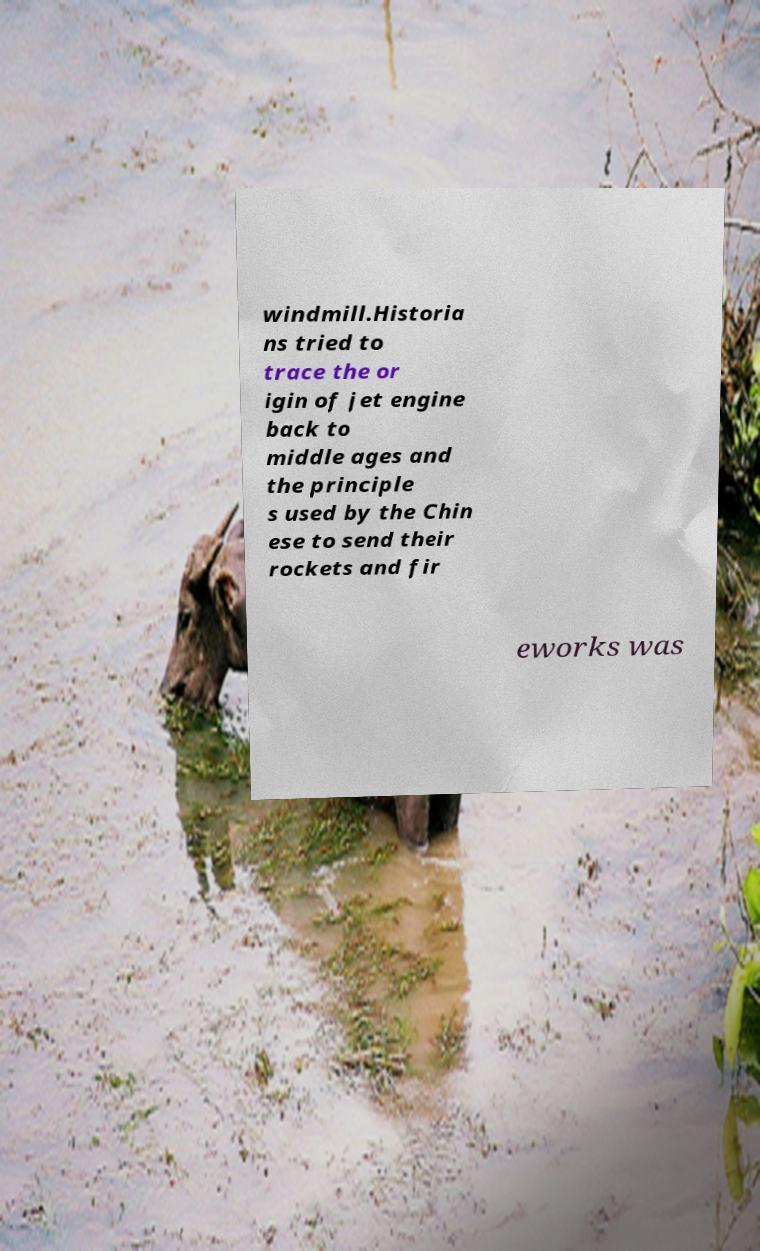Can you accurately transcribe the text from the provided image for me? windmill.Historia ns tried to trace the or igin of jet engine back to middle ages and the principle s used by the Chin ese to send their rockets and fir eworks was 